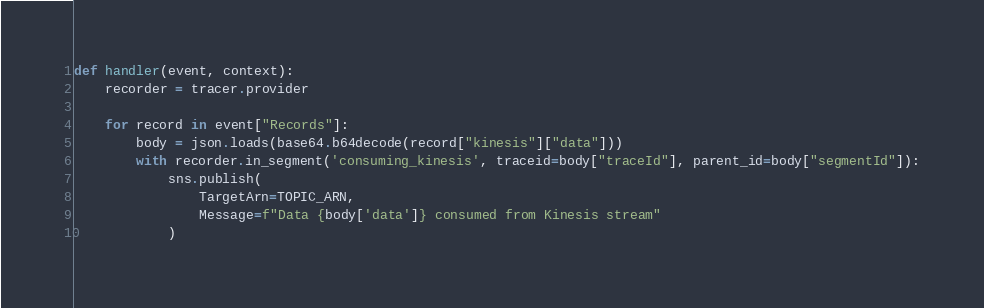Convert code to text. <code><loc_0><loc_0><loc_500><loc_500><_Python_>def handler(event, context):
    recorder = tracer.provider

    for record in event["Records"]:
        body = json.loads(base64.b64decode(record["kinesis"]["data"]))
        with recorder.in_segment('consuming_kinesis', traceid=body["traceId"], parent_id=body["segmentId"]):
            sns.publish(
                TargetArn=TOPIC_ARN,
                Message=f"Data {body['data']} consumed from Kinesis stream"
            )</code> 